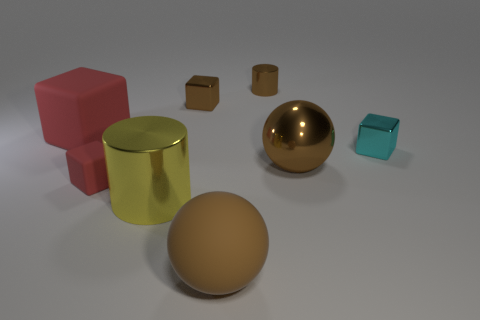Add 1 tiny brown cubes. How many objects exist? 9 Subtract all balls. How many objects are left? 6 Add 6 cyan rubber balls. How many cyan rubber balls exist? 6 Subtract 0 blue cubes. How many objects are left? 8 Subtract all brown balls. Subtract all big cylinders. How many objects are left? 5 Add 8 yellow metal objects. How many yellow metal objects are left? 9 